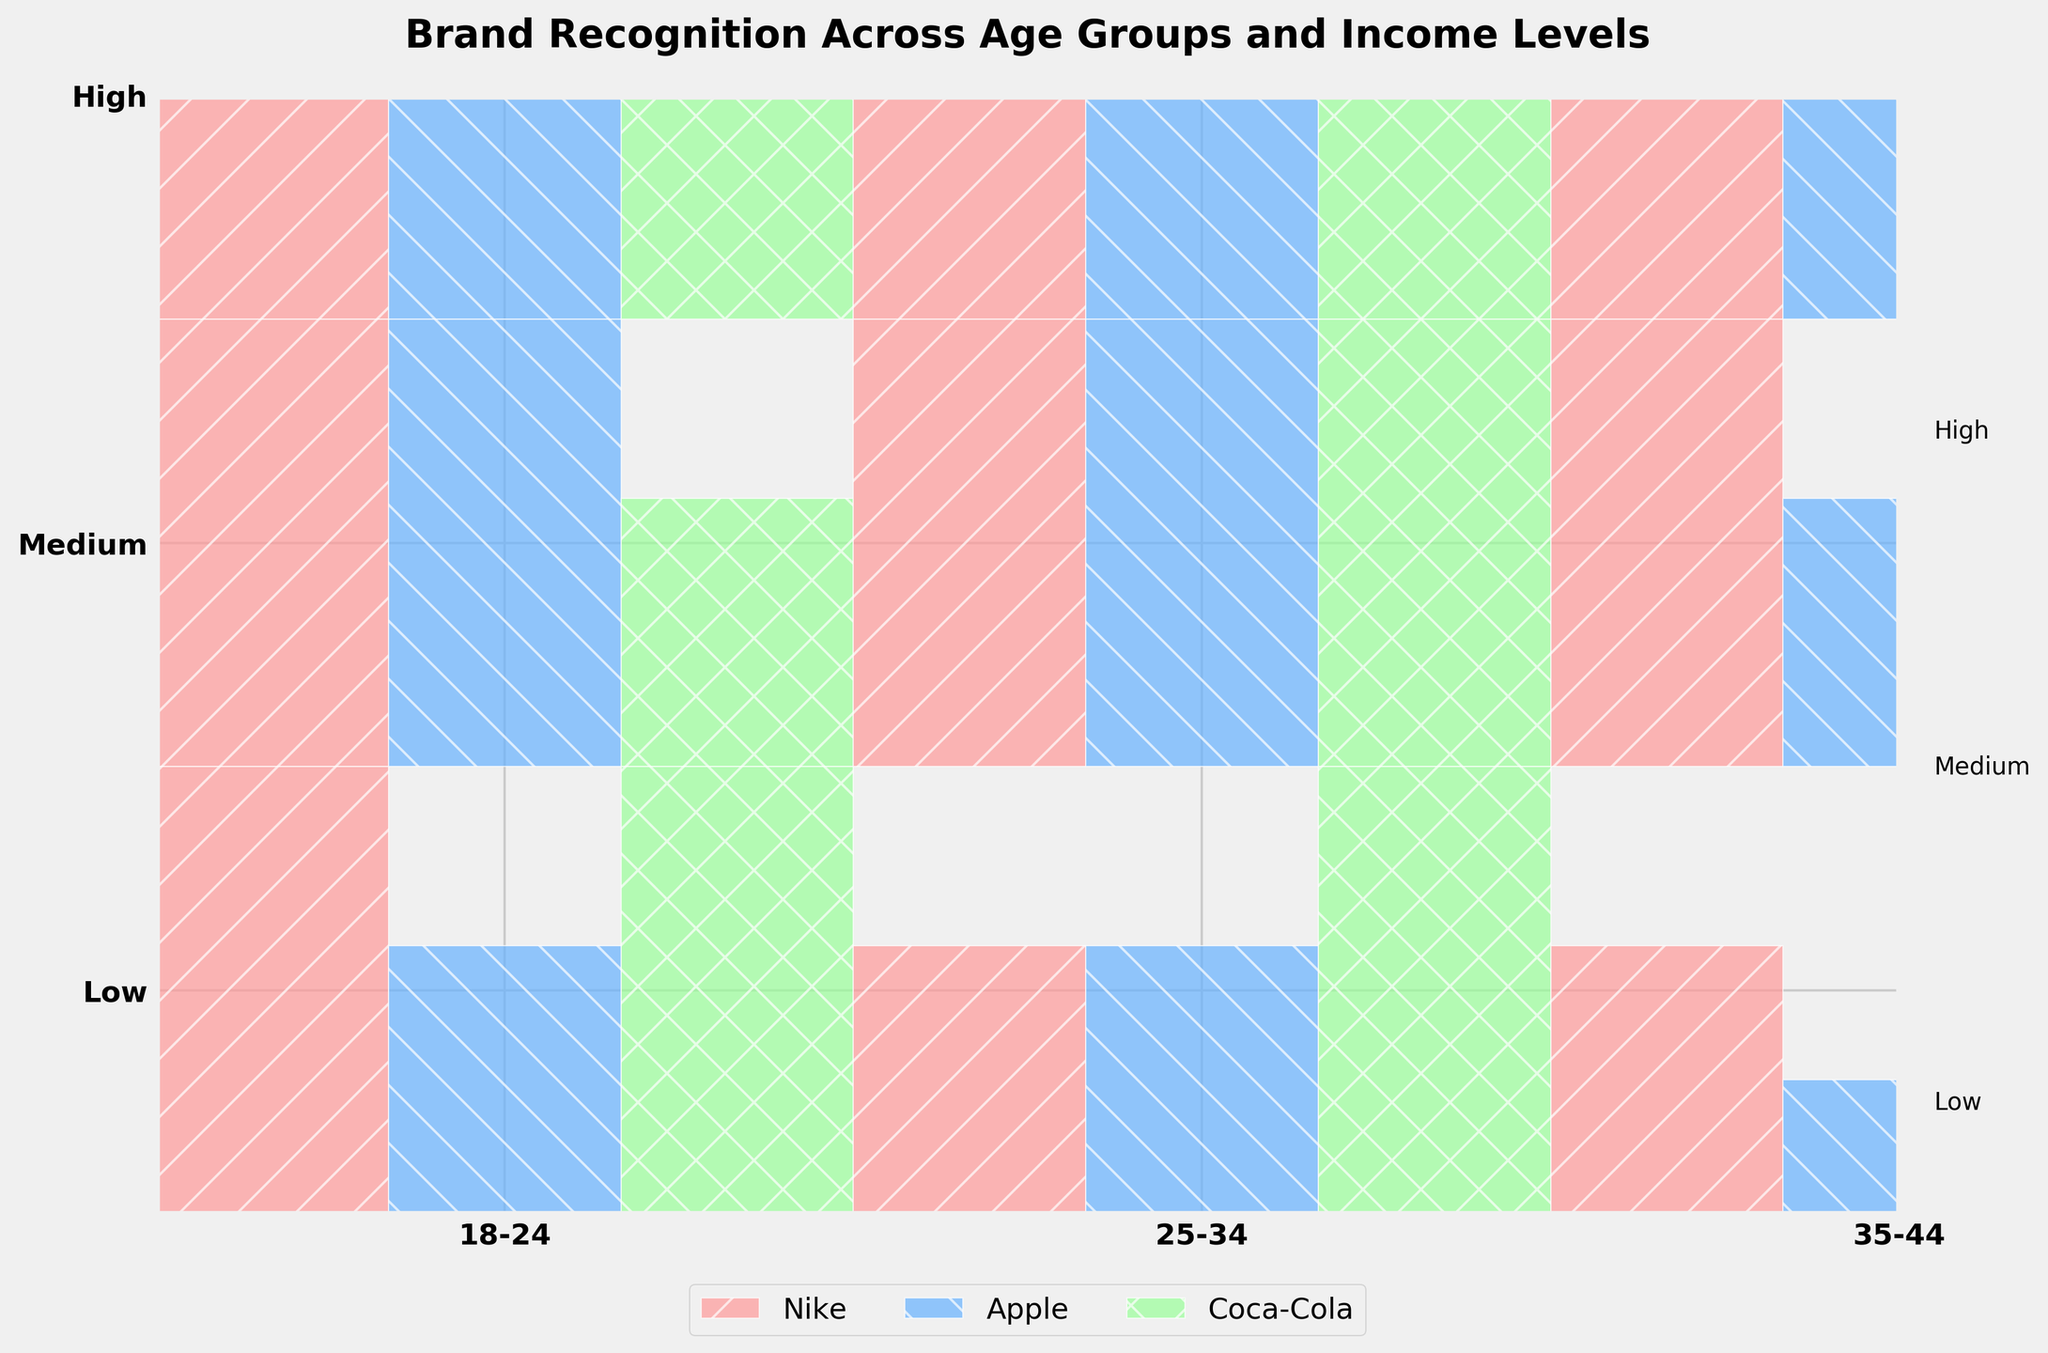What is the title of the figure? The title of the figure is displayed at the top center of the plot. It reads "Brand Recognition Across Age Groups and Income Levels".
Answer: Brand Recognition Across Age Groups and Income Levels Which age group appears on the left-most x-axis tick label? The x-axis tick labels represent the age groups and are presented from left to right. The left-most label reads "18-24".
Answer: 18-24 How is brand recognition visually represented in the plot? Brand recognition is represented by the size of the rectangles within each age and income level cell. Larger rectangles indicate higher recognition levels, while smaller rectangles indicate lower recognition levels.
Answer: By the size of the rectangles Which brand has the highest recognition level across all age groups and income levels combined? By examining the figure, it's evident that "Nike" has the most consistently larger rectangles across most age groups and income levels compared to the other brands, indicating the highest recognition level overall.
Answer: Nike In the "25-34" age group with "High" income level, which brand has the lowest recognition? Navigate to the intersection of the "25-34" age group and "High" income level cells. Among the brands, "Nike," "Apple," and "Coca-Cola," observe the sizes. All rectangles are fully filled, so there's no lower recognition visually depicted for these brands in this combination.
Answer: None (all are high) Between the "18-24" and "35-44" age groups with "Medium" income level, which age group has higher recognition for "Apple"? Check the "Medium" income level for both "18-24" and "35-44" age groups. In the 18-24 age group-Apple intersection, the rectangle is larger (High recognition) compared to a smaller one (Medium recognition) in the 35-44 age group.
Answer: 18-24 How does Coca-Cola recognition differ between the "Low" income levels of the age groups "35-44" and "25-34"? Compare the Coca-Cola rectangles in the cells for "Low" income levels in the "35-44" and "25-34" groups. The size is larger (Higher recognition) in the "35-44" group compared to the smaller (Medium recognition) in the "25-34" group.
Answer: Higher in 35-44 List all recognition levels for Nike within the "18-24" age group. Navigate to the cells for the "18-24" group. For Nike, the recognition levels in the "Low," "Medium," and "High" income levels are High, High, and High, respectively.
Answer: High, High, High Which age group and income level combination shows the lowest recognition for "Apple"? Identify the smallest rectangle for "Apple" across all the age groups and income levels. The smallest size (Low recognition) for "Apple" is in the "35-44" age group with a "Low" income level.
Answer: 35-44, Low 